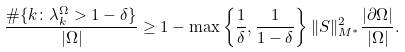<formula> <loc_0><loc_0><loc_500><loc_500>\frac { \# \{ k \colon \lambda _ { k } ^ { \Omega } > 1 - \delta \} } { | \Omega | } \geq 1 - \max \left \{ \frac { 1 } { \delta } , \frac { 1 } { 1 - \delta } \right \} \| S \| _ { M ^ { * } } ^ { 2 } \frac { | \partial \Omega | } { | \Omega | } .</formula> 